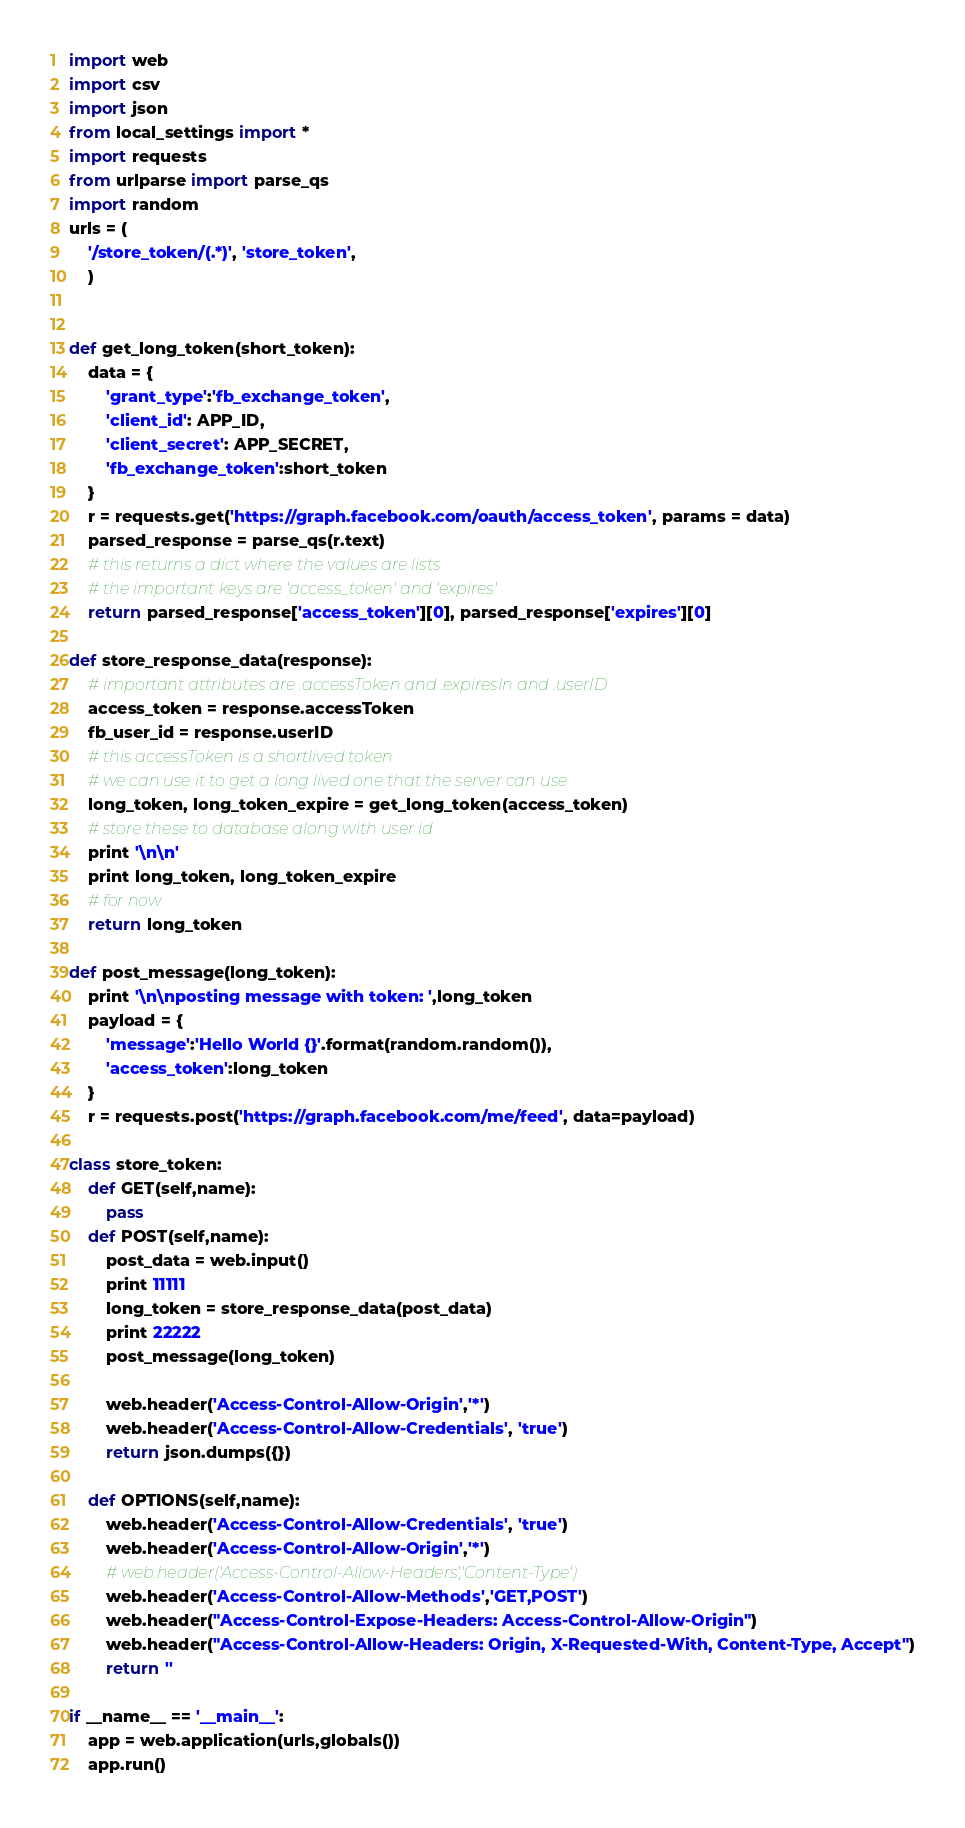<code> <loc_0><loc_0><loc_500><loc_500><_Python_>import web
import csv
import json
from local_settings import *
import requests
from urlparse import parse_qs
import random
urls = (
	'/store_token/(.*)', 'store_token',
	)


def get_long_token(short_token):
	data = {
		'grant_type':'fb_exchange_token',
		'client_id': APP_ID,
		'client_secret': APP_SECRET,
		'fb_exchange_token':short_token
	}
	r = requests.get('https://graph.facebook.com/oauth/access_token', params = data)
	parsed_response = parse_qs(r.text)
	# this returns a dict where the values are lists
	# the important keys are 'access_token' and 'expires'
	return parsed_response['access_token'][0], parsed_response['expires'][0]

def store_response_data(response):
	# important attributes are .accessToken and .expiresIn and .userID
	access_token = response.accessToken
	fb_user_id = response.userID
	# this accessToken is a shortlived token
	# we can use it to get a long lived one that the server can use
	long_token, long_token_expire = get_long_token(access_token)
	# store these to database along with user id
	print '\n\n'
	print long_token, long_token_expire
	# for now
	return long_token

def post_message(long_token):
	print '\n\nposting message with token: ',long_token
	payload = {
		'message':'Hello World {}'.format(random.random()),
		'access_token':long_token
	}
	r = requests.post('https://graph.facebook.com/me/feed', data=payload)

class store_token:
	def GET(self,name):
		pass
	def POST(self,name):
		post_data = web.input()
		print 11111
		long_token = store_response_data(post_data)
		print 22222
		post_message(long_token)
		
		web.header('Access-Control-Allow-Origin','*')
		web.header('Access-Control-Allow-Credentials', 'true')
		return json.dumps({})

	def OPTIONS(self,name):
		web.header('Access-Control-Allow-Credentials', 'true')
		web.header('Access-Control-Allow-Origin','*')
		# web.header('Access-Control-Allow-Headers','Content-Type')
		web.header('Access-Control-Allow-Methods','GET,POST')
		web.header("Access-Control-Expose-Headers: Access-Control-Allow-Origin")
		web.header("Access-Control-Allow-Headers: Origin, X-Requested-With, Content-Type, Accept")
		return ''

if __name__ == '__main__':
	app = web.application(urls,globals())
	app.run()
</code> 